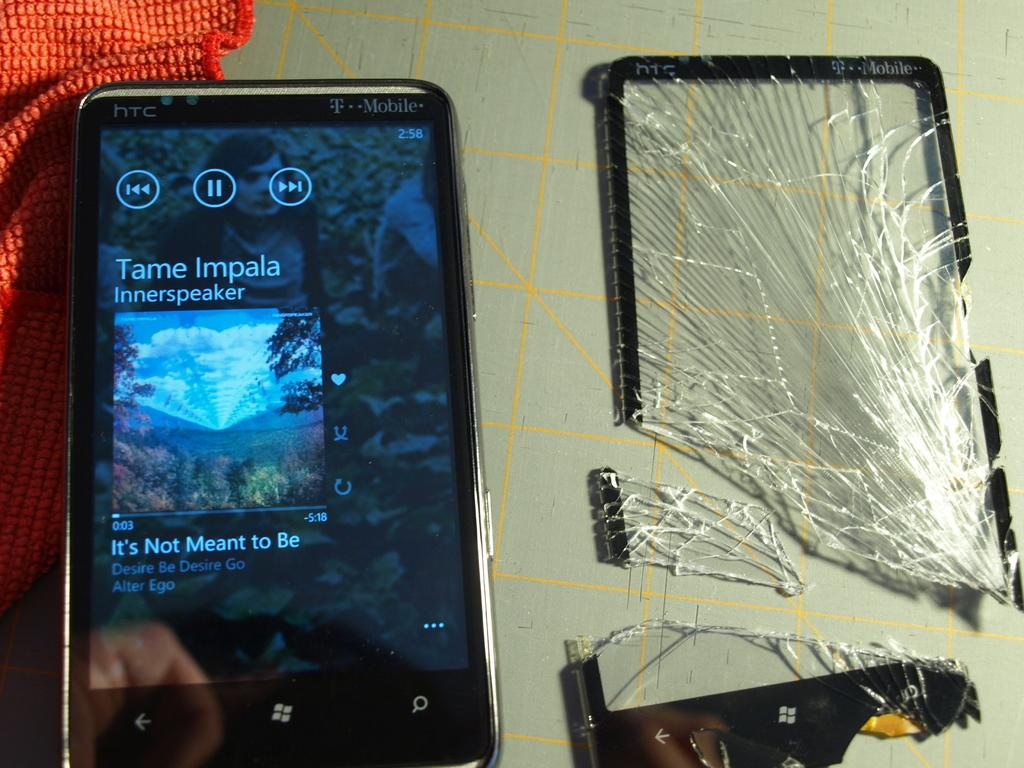<image>
Provide a brief description of the given image. A phone displaying the song it's not meant to be 